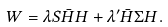<formula> <loc_0><loc_0><loc_500><loc_500>W = \lambda S \bar { H } H + \lambda ^ { \prime } \bar { H } \Sigma H .</formula> 